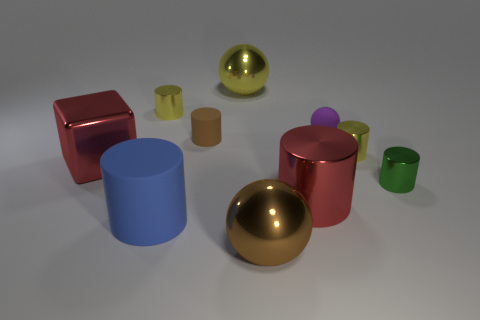Subtract all large brown metal spheres. How many spheres are left? 2 Subtract all red cylinders. How many cylinders are left? 5 Subtract 1 cubes. How many cubes are left? 0 Subtract all cubes. How many objects are left? 9 Subtract all brown balls. How many green cylinders are left? 1 Subtract all red metallic objects. Subtract all yellow cylinders. How many objects are left? 6 Add 3 small cylinders. How many small cylinders are left? 7 Add 3 metal cubes. How many metal cubes exist? 4 Subtract 0 purple cylinders. How many objects are left? 10 Subtract all purple blocks. Subtract all blue balls. How many blocks are left? 1 